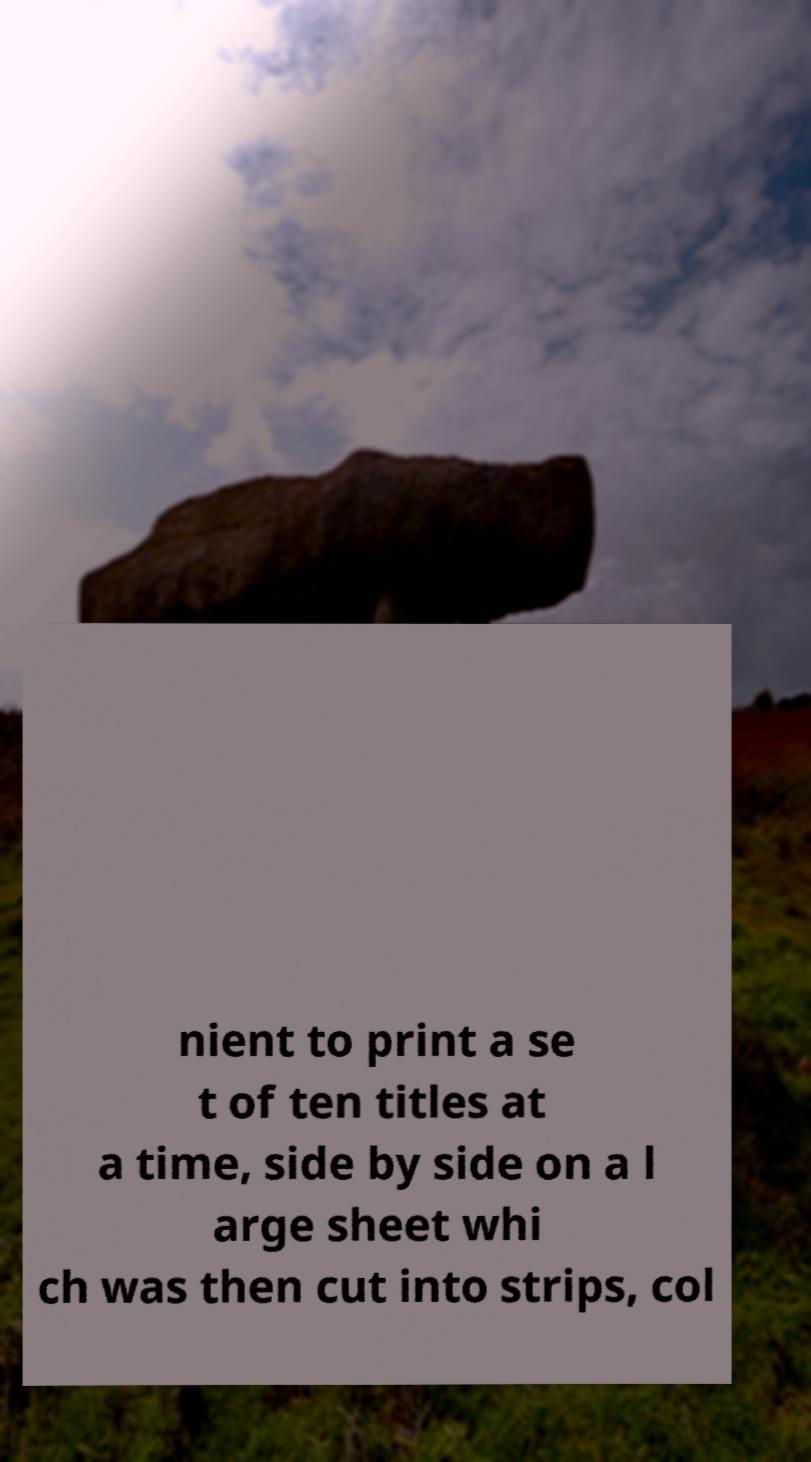What messages or text are displayed in this image? I need them in a readable, typed format. nient to print a se t of ten titles at a time, side by side on a l arge sheet whi ch was then cut into strips, col 